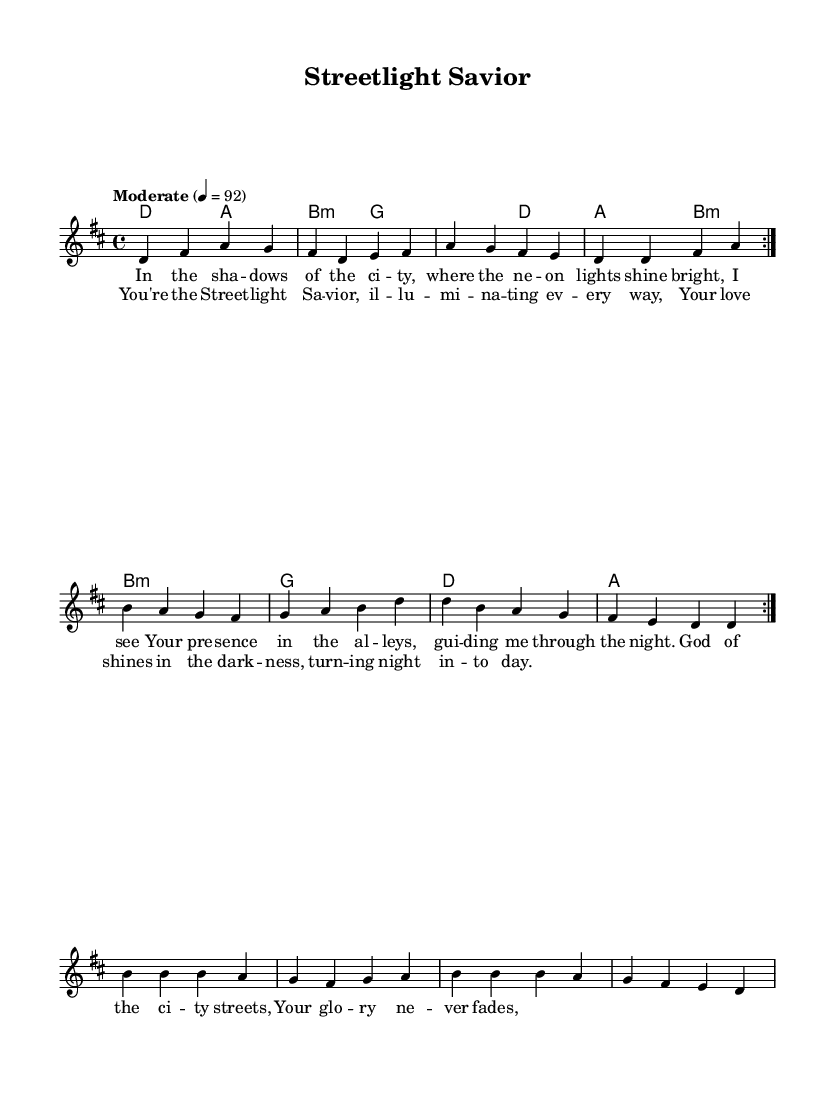What is the key signature of this music? The key signature is D major, which has two sharps (F# and C#). This can be identified by looking at the two sharp symbols placed at the beginning of the staff.
Answer: D major What is the time signature of this music? The time signature is 4/4, which indicates that there are four beats in each measure and the quarter note gets one beat. This is shown at the beginning of the staff right after the key signature.
Answer: 4/4 What is the tempo marking for this piece? The tempo marking is "Moderate" at 92 beats per minute, indicating the speed at which the piece should be played. This is found at the beginning of the score in the tempo section.
Answer: Moderate 4 = 92 How many measures are in the verse section? There are 8 measures in the verse section, as counted from the provided melody line before the repeat and the lyric indication of "verseOne." The repeat does not add further measures; it simply repeats the same content.
Answer: 8 What is the first lyric line of the chorus? The first lyric line of the chorus is "You're the Street -- light Sa -- vior," which is indicated below the melody after the verse section. This can be seen in the lyricst that follow the chorus section in the score.
Answer: You're the Street -- light Sa -- vior What is the last chord played in the harmonies? The last chord played in the harmonies is A major, which can be observed in the final measure of the chord section. This gives the piece a sense of closure at the end.
Answer: A What type of song is this, based on its theme? This is a modern worship song, which is indicated by its references to God's presence and the context of urban life within the lyrics. The themes of light and guidance suggest a worship-oriented purpose.
Answer: Modern worship 